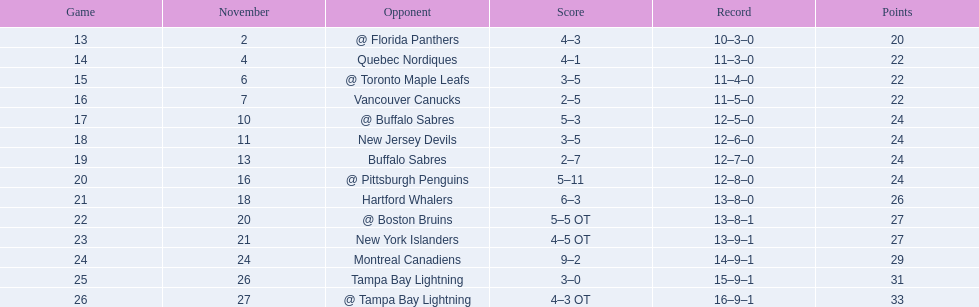What were the point totals of the 1993-94 philadelphia flyers season? 4–3, 4–1, 3–5, 2–5, 5–3, 3–5, 2–7, 5–11, 6–3, 5–5 OT, 4–5 OT, 9–2, 3–0, 4–3 OT. Which of these teams had a 4-5 overtime score? New York Islanders. 